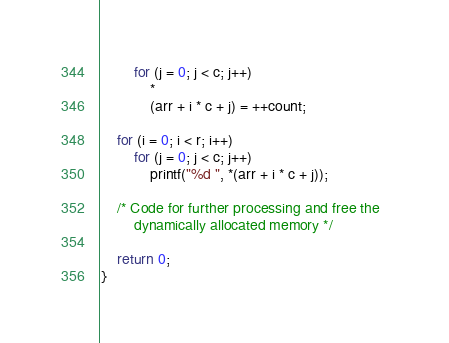<code> <loc_0><loc_0><loc_500><loc_500><_C_>        for (j = 0; j < c; j++)
            *
            (arr + i * c + j) = ++count;

    for (i = 0; i < r; i++)
        for (j = 0; j < c; j++)
            printf("%d ", *(arr + i * c + j));

    /* Code for further processing and free the  
        dynamically allocated memory */

    return 0;
}
</code> 